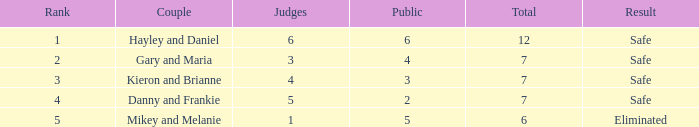Could you parse the entire table? {'header': ['Rank', 'Couple', 'Judges', 'Public', 'Total', 'Result'], 'rows': [['1', 'Hayley and Daniel', '6', '6', '12', 'Safe'], ['2', 'Gary and Maria', '3', '4', '7', 'Safe'], ['3', 'Kieron and Brianne', '4', '3', '7', 'Safe'], ['4', 'Danny and Frankie', '5', '2', '7', 'Safe'], ['5', 'Mikey and Melanie', '1', '5', '6', 'Eliminated']]} How many judges were there for the eliminated couple?  1.0. 